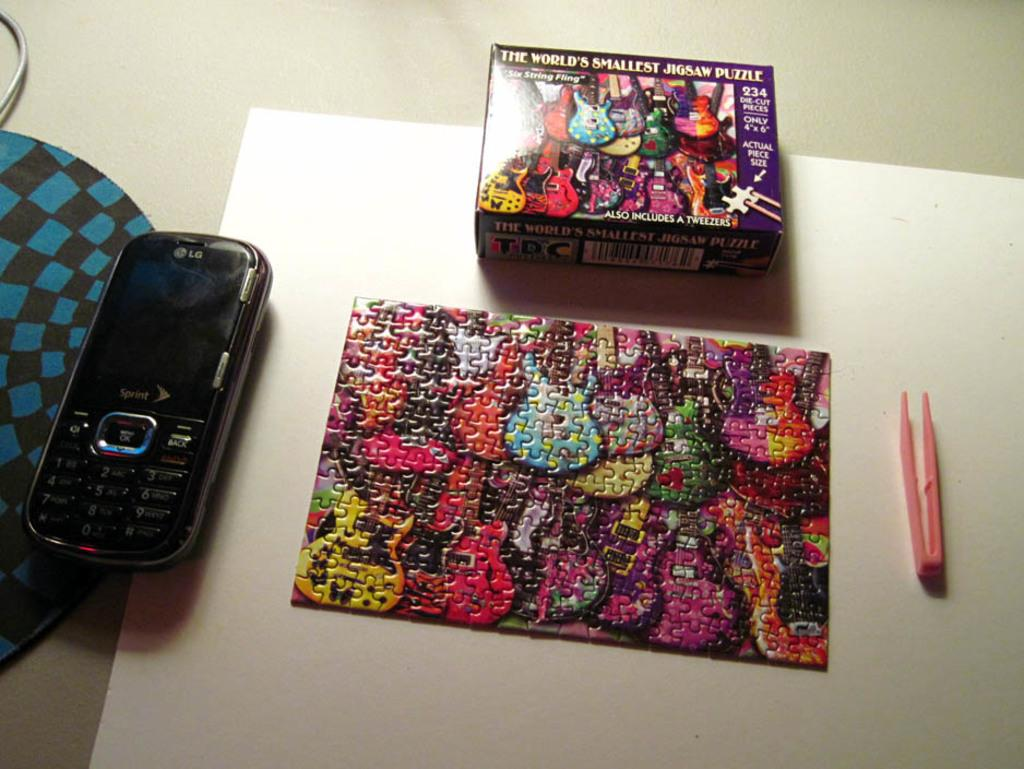<image>
Offer a succinct explanation of the picture presented. An abstract guitar painting puzzle completed by a pen and the puzzle box with a Sprint cellphone beside the puzzle 